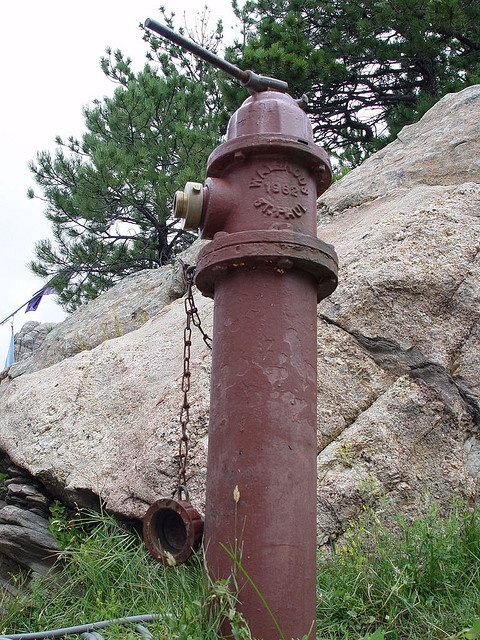Describe the objects in this image and their specific colors. I can see a fire hydrant in white, brown, black, maroon, and gray tones in this image. 